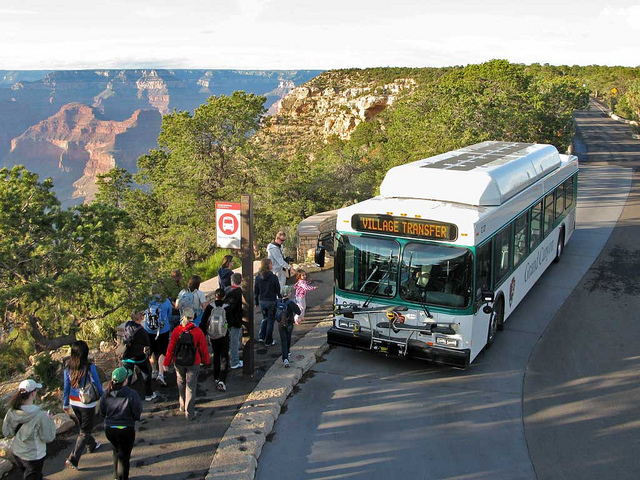<image>What make and model bus is that? I don't know what make and model the bus is. It can be any of chevy, volvo, ford, old volkswagen, or vw. What make and model bus is that? It is unknown what make and model the bus is. 